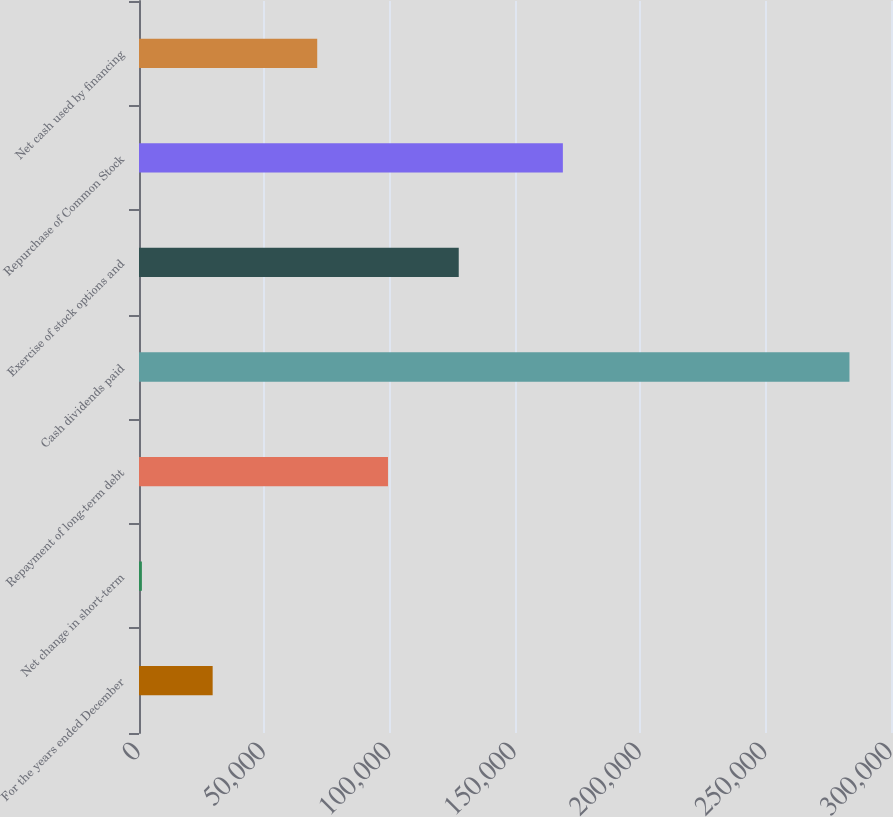Convert chart. <chart><loc_0><loc_0><loc_500><loc_500><bar_chart><fcel>For the years ended December<fcel>Net change in short-term<fcel>Repayment of long-term debt<fcel>Cash dividends paid<fcel>Exercise of stock options and<fcel>Repurchase of Common Stock<fcel>Net cash used by financing<nl><fcel>29383.8<fcel>1156<fcel>99327.8<fcel>283434<fcel>127556<fcel>169099<fcel>71100<nl></chart> 